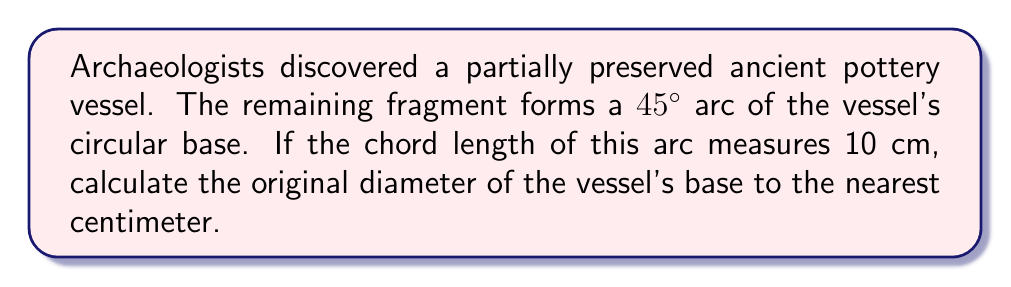What is the answer to this math problem? To solve this problem, we'll use trigonometry and the properties of circles. Let's approach this step-by-step:

1) In a circle, a 45° arc is 1/8 of the full circumference (360° ÷ 45° = 8).

2) The chord of this arc forms an isosceles triangle with two radii of the circle. The angle between these radii is 45°.

3) Let's call the radius of the circle $r$. The chord length (10 cm) is the base of the isosceles triangle.

4) We can split this isosceles triangle into two right triangles. In each of these right triangles:
   - The hypotenuse is $r$
   - Half of the chord length is 5 cm (opposite side)
   - The angle between the radius and chord is 22.5° (half of 45°)

5) Using the sine function in this right triangle:

   $$\sin(22.5°) = \frac{5}{r}$$

6) Solving for $r$:

   $$r = \frac{5}{\sin(22.5°)}$$

7) Using a calculator (or knowing that $\sin(22.5°) \approx 0.3827$):

   $$r \approx \frac{5}{0.3827} \approx 13.06 \text{ cm}$$

8) The diameter is twice the radius:

   $$\text{diameter} \approx 2 * 13.06 = 26.12 \text{ cm}$$

9) Rounding to the nearest centimeter:

   $$\text{diameter} \approx 26 \text{ cm}$$
Answer: 26 cm 